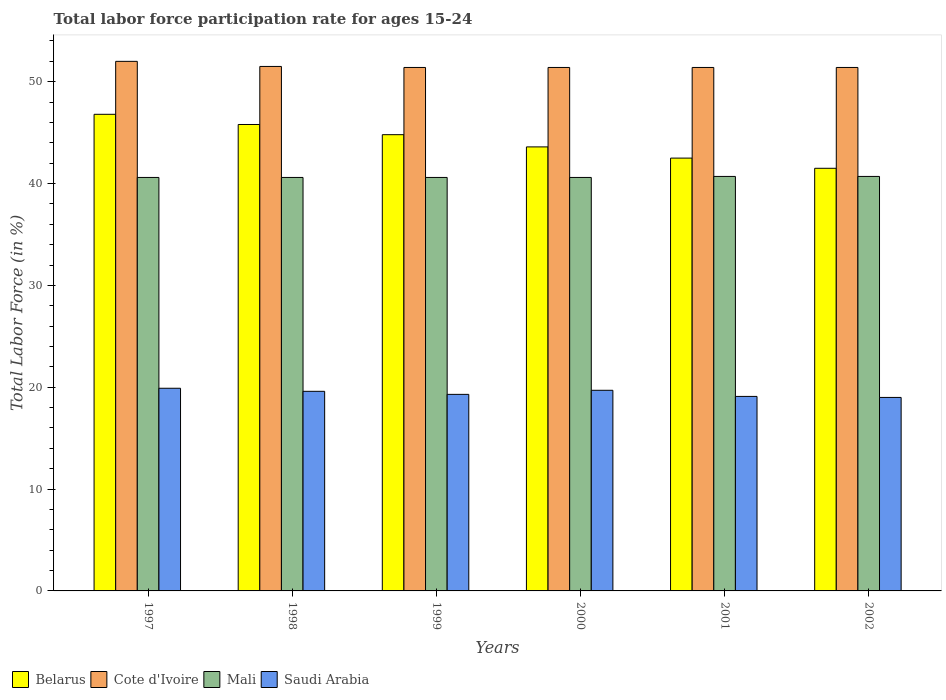Are the number of bars per tick equal to the number of legend labels?
Make the answer very short. Yes. How many bars are there on the 4th tick from the right?
Offer a terse response. 4. What is the labor force participation rate in Saudi Arabia in 1998?
Ensure brevity in your answer.  19.6. Across all years, what is the maximum labor force participation rate in Saudi Arabia?
Your answer should be very brief. 19.9. Across all years, what is the minimum labor force participation rate in Cote d'Ivoire?
Make the answer very short. 51.4. In which year was the labor force participation rate in Cote d'Ivoire minimum?
Your response must be concise. 1999. What is the total labor force participation rate in Saudi Arabia in the graph?
Provide a short and direct response. 116.6. What is the difference between the labor force participation rate in Belarus in 2000 and the labor force participation rate in Mali in 2001?
Offer a very short reply. 2.9. What is the average labor force participation rate in Cote d'Ivoire per year?
Make the answer very short. 51.52. In the year 1999, what is the difference between the labor force participation rate in Mali and labor force participation rate in Belarus?
Your answer should be compact. -4.2. In how many years, is the labor force participation rate in Cote d'Ivoire greater than 20 %?
Your response must be concise. 6. What is the ratio of the labor force participation rate in Saudi Arabia in 1997 to that in 1998?
Ensure brevity in your answer.  1.02. Is the labor force participation rate in Saudi Arabia in 1999 less than that in 2002?
Give a very brief answer. No. Is the difference between the labor force participation rate in Mali in 1998 and 1999 greater than the difference between the labor force participation rate in Belarus in 1998 and 1999?
Provide a short and direct response. No. What is the difference between the highest and the second highest labor force participation rate in Saudi Arabia?
Your answer should be very brief. 0.2. What is the difference between the highest and the lowest labor force participation rate in Belarus?
Offer a very short reply. 5.3. Is the sum of the labor force participation rate in Belarus in 1998 and 2001 greater than the maximum labor force participation rate in Saudi Arabia across all years?
Your answer should be compact. Yes. Is it the case that in every year, the sum of the labor force participation rate in Belarus and labor force participation rate in Saudi Arabia is greater than the sum of labor force participation rate in Mali and labor force participation rate in Cote d'Ivoire?
Provide a succinct answer. No. What does the 4th bar from the left in 2000 represents?
Give a very brief answer. Saudi Arabia. What does the 1st bar from the right in 2000 represents?
Provide a succinct answer. Saudi Arabia. Are all the bars in the graph horizontal?
Make the answer very short. No. Does the graph contain any zero values?
Keep it short and to the point. No. Does the graph contain grids?
Provide a succinct answer. No. Where does the legend appear in the graph?
Make the answer very short. Bottom left. How are the legend labels stacked?
Your answer should be very brief. Horizontal. What is the title of the graph?
Give a very brief answer. Total labor force participation rate for ages 15-24. What is the Total Labor Force (in %) of Belarus in 1997?
Offer a terse response. 46.8. What is the Total Labor Force (in %) of Cote d'Ivoire in 1997?
Ensure brevity in your answer.  52. What is the Total Labor Force (in %) in Mali in 1997?
Give a very brief answer. 40.6. What is the Total Labor Force (in %) in Saudi Arabia in 1997?
Your answer should be very brief. 19.9. What is the Total Labor Force (in %) in Belarus in 1998?
Your answer should be compact. 45.8. What is the Total Labor Force (in %) of Cote d'Ivoire in 1998?
Offer a terse response. 51.5. What is the Total Labor Force (in %) of Mali in 1998?
Offer a very short reply. 40.6. What is the Total Labor Force (in %) of Saudi Arabia in 1998?
Your answer should be very brief. 19.6. What is the Total Labor Force (in %) in Belarus in 1999?
Provide a short and direct response. 44.8. What is the Total Labor Force (in %) of Cote d'Ivoire in 1999?
Offer a very short reply. 51.4. What is the Total Labor Force (in %) in Mali in 1999?
Give a very brief answer. 40.6. What is the Total Labor Force (in %) in Saudi Arabia in 1999?
Your answer should be very brief. 19.3. What is the Total Labor Force (in %) of Belarus in 2000?
Give a very brief answer. 43.6. What is the Total Labor Force (in %) in Cote d'Ivoire in 2000?
Your answer should be compact. 51.4. What is the Total Labor Force (in %) of Mali in 2000?
Your answer should be compact. 40.6. What is the Total Labor Force (in %) in Saudi Arabia in 2000?
Offer a very short reply. 19.7. What is the Total Labor Force (in %) in Belarus in 2001?
Make the answer very short. 42.5. What is the Total Labor Force (in %) of Cote d'Ivoire in 2001?
Give a very brief answer. 51.4. What is the Total Labor Force (in %) in Mali in 2001?
Your response must be concise. 40.7. What is the Total Labor Force (in %) of Saudi Arabia in 2001?
Make the answer very short. 19.1. What is the Total Labor Force (in %) of Belarus in 2002?
Ensure brevity in your answer.  41.5. What is the Total Labor Force (in %) in Cote d'Ivoire in 2002?
Provide a succinct answer. 51.4. What is the Total Labor Force (in %) of Mali in 2002?
Your response must be concise. 40.7. What is the Total Labor Force (in %) in Saudi Arabia in 2002?
Make the answer very short. 19. Across all years, what is the maximum Total Labor Force (in %) of Belarus?
Ensure brevity in your answer.  46.8. Across all years, what is the maximum Total Labor Force (in %) of Mali?
Offer a terse response. 40.7. Across all years, what is the maximum Total Labor Force (in %) in Saudi Arabia?
Give a very brief answer. 19.9. Across all years, what is the minimum Total Labor Force (in %) of Belarus?
Your answer should be compact. 41.5. Across all years, what is the minimum Total Labor Force (in %) of Cote d'Ivoire?
Your answer should be compact. 51.4. Across all years, what is the minimum Total Labor Force (in %) of Mali?
Ensure brevity in your answer.  40.6. What is the total Total Labor Force (in %) of Belarus in the graph?
Make the answer very short. 265. What is the total Total Labor Force (in %) in Cote d'Ivoire in the graph?
Your answer should be very brief. 309.1. What is the total Total Labor Force (in %) of Mali in the graph?
Your response must be concise. 243.8. What is the total Total Labor Force (in %) of Saudi Arabia in the graph?
Give a very brief answer. 116.6. What is the difference between the Total Labor Force (in %) of Belarus in 1997 and that in 1998?
Make the answer very short. 1. What is the difference between the Total Labor Force (in %) in Cote d'Ivoire in 1997 and that in 1998?
Your response must be concise. 0.5. What is the difference between the Total Labor Force (in %) in Saudi Arabia in 1997 and that in 1998?
Your answer should be very brief. 0.3. What is the difference between the Total Labor Force (in %) in Mali in 1997 and that in 1999?
Make the answer very short. 0. What is the difference between the Total Labor Force (in %) in Saudi Arabia in 1997 and that in 1999?
Offer a very short reply. 0.6. What is the difference between the Total Labor Force (in %) of Mali in 1997 and that in 2000?
Keep it short and to the point. 0. What is the difference between the Total Labor Force (in %) of Mali in 1997 and that in 2001?
Keep it short and to the point. -0.1. What is the difference between the Total Labor Force (in %) of Saudi Arabia in 1997 and that in 2001?
Keep it short and to the point. 0.8. What is the difference between the Total Labor Force (in %) in Belarus in 1997 and that in 2002?
Your answer should be compact. 5.3. What is the difference between the Total Labor Force (in %) of Mali in 1997 and that in 2002?
Give a very brief answer. -0.1. What is the difference between the Total Labor Force (in %) of Belarus in 1998 and that in 1999?
Provide a short and direct response. 1. What is the difference between the Total Labor Force (in %) in Saudi Arabia in 1998 and that in 1999?
Ensure brevity in your answer.  0.3. What is the difference between the Total Labor Force (in %) of Belarus in 1998 and that in 2000?
Provide a succinct answer. 2.2. What is the difference between the Total Labor Force (in %) of Cote d'Ivoire in 1998 and that in 2000?
Provide a succinct answer. 0.1. What is the difference between the Total Labor Force (in %) in Mali in 1998 and that in 2000?
Your answer should be very brief. 0. What is the difference between the Total Labor Force (in %) in Belarus in 1998 and that in 2001?
Give a very brief answer. 3.3. What is the difference between the Total Labor Force (in %) of Saudi Arabia in 1998 and that in 2001?
Offer a terse response. 0.5. What is the difference between the Total Labor Force (in %) of Cote d'Ivoire in 1998 and that in 2002?
Your answer should be very brief. 0.1. What is the difference between the Total Labor Force (in %) of Mali in 1998 and that in 2002?
Your answer should be compact. -0.1. What is the difference between the Total Labor Force (in %) in Belarus in 1999 and that in 2000?
Make the answer very short. 1.2. What is the difference between the Total Labor Force (in %) of Cote d'Ivoire in 1999 and that in 2000?
Ensure brevity in your answer.  0. What is the difference between the Total Labor Force (in %) in Mali in 1999 and that in 2000?
Provide a succinct answer. 0. What is the difference between the Total Labor Force (in %) of Saudi Arabia in 1999 and that in 2000?
Offer a terse response. -0.4. What is the difference between the Total Labor Force (in %) of Cote d'Ivoire in 1999 and that in 2001?
Your answer should be very brief. 0. What is the difference between the Total Labor Force (in %) of Mali in 1999 and that in 2001?
Offer a terse response. -0.1. What is the difference between the Total Labor Force (in %) of Saudi Arabia in 1999 and that in 2001?
Offer a very short reply. 0.2. What is the difference between the Total Labor Force (in %) in Cote d'Ivoire in 1999 and that in 2002?
Give a very brief answer. 0. What is the difference between the Total Labor Force (in %) of Mali in 1999 and that in 2002?
Provide a short and direct response. -0.1. What is the difference between the Total Labor Force (in %) in Cote d'Ivoire in 2000 and that in 2001?
Make the answer very short. 0. What is the difference between the Total Labor Force (in %) of Belarus in 2000 and that in 2002?
Give a very brief answer. 2.1. What is the difference between the Total Labor Force (in %) in Saudi Arabia in 2000 and that in 2002?
Your response must be concise. 0.7. What is the difference between the Total Labor Force (in %) of Mali in 2001 and that in 2002?
Provide a short and direct response. 0. What is the difference between the Total Labor Force (in %) in Saudi Arabia in 2001 and that in 2002?
Your answer should be very brief. 0.1. What is the difference between the Total Labor Force (in %) in Belarus in 1997 and the Total Labor Force (in %) in Mali in 1998?
Your response must be concise. 6.2. What is the difference between the Total Labor Force (in %) of Belarus in 1997 and the Total Labor Force (in %) of Saudi Arabia in 1998?
Your response must be concise. 27.2. What is the difference between the Total Labor Force (in %) in Cote d'Ivoire in 1997 and the Total Labor Force (in %) in Saudi Arabia in 1998?
Offer a very short reply. 32.4. What is the difference between the Total Labor Force (in %) of Mali in 1997 and the Total Labor Force (in %) of Saudi Arabia in 1998?
Keep it short and to the point. 21. What is the difference between the Total Labor Force (in %) of Cote d'Ivoire in 1997 and the Total Labor Force (in %) of Mali in 1999?
Provide a short and direct response. 11.4. What is the difference between the Total Labor Force (in %) of Cote d'Ivoire in 1997 and the Total Labor Force (in %) of Saudi Arabia in 1999?
Offer a very short reply. 32.7. What is the difference between the Total Labor Force (in %) in Mali in 1997 and the Total Labor Force (in %) in Saudi Arabia in 1999?
Your answer should be very brief. 21.3. What is the difference between the Total Labor Force (in %) in Belarus in 1997 and the Total Labor Force (in %) in Saudi Arabia in 2000?
Keep it short and to the point. 27.1. What is the difference between the Total Labor Force (in %) of Cote d'Ivoire in 1997 and the Total Labor Force (in %) of Saudi Arabia in 2000?
Ensure brevity in your answer.  32.3. What is the difference between the Total Labor Force (in %) in Mali in 1997 and the Total Labor Force (in %) in Saudi Arabia in 2000?
Keep it short and to the point. 20.9. What is the difference between the Total Labor Force (in %) in Belarus in 1997 and the Total Labor Force (in %) in Mali in 2001?
Make the answer very short. 6.1. What is the difference between the Total Labor Force (in %) of Belarus in 1997 and the Total Labor Force (in %) of Saudi Arabia in 2001?
Provide a short and direct response. 27.7. What is the difference between the Total Labor Force (in %) of Cote d'Ivoire in 1997 and the Total Labor Force (in %) of Mali in 2001?
Provide a succinct answer. 11.3. What is the difference between the Total Labor Force (in %) in Cote d'Ivoire in 1997 and the Total Labor Force (in %) in Saudi Arabia in 2001?
Provide a short and direct response. 32.9. What is the difference between the Total Labor Force (in %) of Belarus in 1997 and the Total Labor Force (in %) of Saudi Arabia in 2002?
Your answer should be compact. 27.8. What is the difference between the Total Labor Force (in %) in Cote d'Ivoire in 1997 and the Total Labor Force (in %) in Saudi Arabia in 2002?
Make the answer very short. 33. What is the difference between the Total Labor Force (in %) of Mali in 1997 and the Total Labor Force (in %) of Saudi Arabia in 2002?
Keep it short and to the point. 21.6. What is the difference between the Total Labor Force (in %) of Belarus in 1998 and the Total Labor Force (in %) of Cote d'Ivoire in 1999?
Keep it short and to the point. -5.6. What is the difference between the Total Labor Force (in %) of Belarus in 1998 and the Total Labor Force (in %) of Mali in 1999?
Provide a succinct answer. 5.2. What is the difference between the Total Labor Force (in %) in Cote d'Ivoire in 1998 and the Total Labor Force (in %) in Mali in 1999?
Offer a very short reply. 10.9. What is the difference between the Total Labor Force (in %) of Cote d'Ivoire in 1998 and the Total Labor Force (in %) of Saudi Arabia in 1999?
Give a very brief answer. 32.2. What is the difference between the Total Labor Force (in %) in Mali in 1998 and the Total Labor Force (in %) in Saudi Arabia in 1999?
Offer a terse response. 21.3. What is the difference between the Total Labor Force (in %) in Belarus in 1998 and the Total Labor Force (in %) in Cote d'Ivoire in 2000?
Make the answer very short. -5.6. What is the difference between the Total Labor Force (in %) in Belarus in 1998 and the Total Labor Force (in %) in Mali in 2000?
Give a very brief answer. 5.2. What is the difference between the Total Labor Force (in %) of Belarus in 1998 and the Total Labor Force (in %) of Saudi Arabia in 2000?
Ensure brevity in your answer.  26.1. What is the difference between the Total Labor Force (in %) in Cote d'Ivoire in 1998 and the Total Labor Force (in %) in Saudi Arabia in 2000?
Offer a terse response. 31.8. What is the difference between the Total Labor Force (in %) in Mali in 1998 and the Total Labor Force (in %) in Saudi Arabia in 2000?
Your answer should be compact. 20.9. What is the difference between the Total Labor Force (in %) of Belarus in 1998 and the Total Labor Force (in %) of Cote d'Ivoire in 2001?
Your response must be concise. -5.6. What is the difference between the Total Labor Force (in %) of Belarus in 1998 and the Total Labor Force (in %) of Mali in 2001?
Make the answer very short. 5.1. What is the difference between the Total Labor Force (in %) in Belarus in 1998 and the Total Labor Force (in %) in Saudi Arabia in 2001?
Your answer should be very brief. 26.7. What is the difference between the Total Labor Force (in %) in Cote d'Ivoire in 1998 and the Total Labor Force (in %) in Saudi Arabia in 2001?
Make the answer very short. 32.4. What is the difference between the Total Labor Force (in %) of Belarus in 1998 and the Total Labor Force (in %) of Mali in 2002?
Provide a short and direct response. 5.1. What is the difference between the Total Labor Force (in %) in Belarus in 1998 and the Total Labor Force (in %) in Saudi Arabia in 2002?
Make the answer very short. 26.8. What is the difference between the Total Labor Force (in %) in Cote d'Ivoire in 1998 and the Total Labor Force (in %) in Saudi Arabia in 2002?
Your response must be concise. 32.5. What is the difference between the Total Labor Force (in %) in Mali in 1998 and the Total Labor Force (in %) in Saudi Arabia in 2002?
Provide a short and direct response. 21.6. What is the difference between the Total Labor Force (in %) of Belarus in 1999 and the Total Labor Force (in %) of Cote d'Ivoire in 2000?
Your answer should be very brief. -6.6. What is the difference between the Total Labor Force (in %) in Belarus in 1999 and the Total Labor Force (in %) in Mali in 2000?
Ensure brevity in your answer.  4.2. What is the difference between the Total Labor Force (in %) of Belarus in 1999 and the Total Labor Force (in %) of Saudi Arabia in 2000?
Your response must be concise. 25.1. What is the difference between the Total Labor Force (in %) of Cote d'Ivoire in 1999 and the Total Labor Force (in %) of Mali in 2000?
Offer a very short reply. 10.8. What is the difference between the Total Labor Force (in %) of Cote d'Ivoire in 1999 and the Total Labor Force (in %) of Saudi Arabia in 2000?
Keep it short and to the point. 31.7. What is the difference between the Total Labor Force (in %) in Mali in 1999 and the Total Labor Force (in %) in Saudi Arabia in 2000?
Ensure brevity in your answer.  20.9. What is the difference between the Total Labor Force (in %) of Belarus in 1999 and the Total Labor Force (in %) of Saudi Arabia in 2001?
Your answer should be compact. 25.7. What is the difference between the Total Labor Force (in %) of Cote d'Ivoire in 1999 and the Total Labor Force (in %) of Saudi Arabia in 2001?
Your answer should be very brief. 32.3. What is the difference between the Total Labor Force (in %) in Belarus in 1999 and the Total Labor Force (in %) in Cote d'Ivoire in 2002?
Give a very brief answer. -6.6. What is the difference between the Total Labor Force (in %) of Belarus in 1999 and the Total Labor Force (in %) of Mali in 2002?
Offer a very short reply. 4.1. What is the difference between the Total Labor Force (in %) in Belarus in 1999 and the Total Labor Force (in %) in Saudi Arabia in 2002?
Offer a terse response. 25.8. What is the difference between the Total Labor Force (in %) in Cote d'Ivoire in 1999 and the Total Labor Force (in %) in Saudi Arabia in 2002?
Your answer should be very brief. 32.4. What is the difference between the Total Labor Force (in %) in Mali in 1999 and the Total Labor Force (in %) in Saudi Arabia in 2002?
Give a very brief answer. 21.6. What is the difference between the Total Labor Force (in %) of Belarus in 2000 and the Total Labor Force (in %) of Mali in 2001?
Your answer should be very brief. 2.9. What is the difference between the Total Labor Force (in %) in Belarus in 2000 and the Total Labor Force (in %) in Saudi Arabia in 2001?
Make the answer very short. 24.5. What is the difference between the Total Labor Force (in %) in Cote d'Ivoire in 2000 and the Total Labor Force (in %) in Saudi Arabia in 2001?
Your answer should be compact. 32.3. What is the difference between the Total Labor Force (in %) in Belarus in 2000 and the Total Labor Force (in %) in Mali in 2002?
Your response must be concise. 2.9. What is the difference between the Total Labor Force (in %) of Belarus in 2000 and the Total Labor Force (in %) of Saudi Arabia in 2002?
Your answer should be compact. 24.6. What is the difference between the Total Labor Force (in %) of Cote d'Ivoire in 2000 and the Total Labor Force (in %) of Mali in 2002?
Your response must be concise. 10.7. What is the difference between the Total Labor Force (in %) in Cote d'Ivoire in 2000 and the Total Labor Force (in %) in Saudi Arabia in 2002?
Provide a succinct answer. 32.4. What is the difference between the Total Labor Force (in %) in Mali in 2000 and the Total Labor Force (in %) in Saudi Arabia in 2002?
Ensure brevity in your answer.  21.6. What is the difference between the Total Labor Force (in %) in Cote d'Ivoire in 2001 and the Total Labor Force (in %) in Saudi Arabia in 2002?
Your answer should be very brief. 32.4. What is the difference between the Total Labor Force (in %) in Mali in 2001 and the Total Labor Force (in %) in Saudi Arabia in 2002?
Your response must be concise. 21.7. What is the average Total Labor Force (in %) in Belarus per year?
Ensure brevity in your answer.  44.17. What is the average Total Labor Force (in %) in Cote d'Ivoire per year?
Provide a short and direct response. 51.52. What is the average Total Labor Force (in %) in Mali per year?
Offer a terse response. 40.63. What is the average Total Labor Force (in %) in Saudi Arabia per year?
Offer a terse response. 19.43. In the year 1997, what is the difference between the Total Labor Force (in %) in Belarus and Total Labor Force (in %) in Cote d'Ivoire?
Your answer should be compact. -5.2. In the year 1997, what is the difference between the Total Labor Force (in %) of Belarus and Total Labor Force (in %) of Saudi Arabia?
Your answer should be compact. 26.9. In the year 1997, what is the difference between the Total Labor Force (in %) in Cote d'Ivoire and Total Labor Force (in %) in Mali?
Ensure brevity in your answer.  11.4. In the year 1997, what is the difference between the Total Labor Force (in %) of Cote d'Ivoire and Total Labor Force (in %) of Saudi Arabia?
Ensure brevity in your answer.  32.1. In the year 1997, what is the difference between the Total Labor Force (in %) of Mali and Total Labor Force (in %) of Saudi Arabia?
Offer a terse response. 20.7. In the year 1998, what is the difference between the Total Labor Force (in %) of Belarus and Total Labor Force (in %) of Mali?
Offer a very short reply. 5.2. In the year 1998, what is the difference between the Total Labor Force (in %) in Belarus and Total Labor Force (in %) in Saudi Arabia?
Offer a very short reply. 26.2. In the year 1998, what is the difference between the Total Labor Force (in %) of Cote d'Ivoire and Total Labor Force (in %) of Saudi Arabia?
Provide a short and direct response. 31.9. In the year 1998, what is the difference between the Total Labor Force (in %) in Mali and Total Labor Force (in %) in Saudi Arabia?
Make the answer very short. 21. In the year 1999, what is the difference between the Total Labor Force (in %) in Belarus and Total Labor Force (in %) in Mali?
Your answer should be very brief. 4.2. In the year 1999, what is the difference between the Total Labor Force (in %) of Belarus and Total Labor Force (in %) of Saudi Arabia?
Your response must be concise. 25.5. In the year 1999, what is the difference between the Total Labor Force (in %) of Cote d'Ivoire and Total Labor Force (in %) of Saudi Arabia?
Give a very brief answer. 32.1. In the year 1999, what is the difference between the Total Labor Force (in %) in Mali and Total Labor Force (in %) in Saudi Arabia?
Your answer should be compact. 21.3. In the year 2000, what is the difference between the Total Labor Force (in %) of Belarus and Total Labor Force (in %) of Cote d'Ivoire?
Your answer should be compact. -7.8. In the year 2000, what is the difference between the Total Labor Force (in %) in Belarus and Total Labor Force (in %) in Mali?
Your answer should be very brief. 3. In the year 2000, what is the difference between the Total Labor Force (in %) in Belarus and Total Labor Force (in %) in Saudi Arabia?
Offer a very short reply. 23.9. In the year 2000, what is the difference between the Total Labor Force (in %) in Cote d'Ivoire and Total Labor Force (in %) in Saudi Arabia?
Provide a short and direct response. 31.7. In the year 2000, what is the difference between the Total Labor Force (in %) of Mali and Total Labor Force (in %) of Saudi Arabia?
Provide a short and direct response. 20.9. In the year 2001, what is the difference between the Total Labor Force (in %) of Belarus and Total Labor Force (in %) of Mali?
Offer a very short reply. 1.8. In the year 2001, what is the difference between the Total Labor Force (in %) of Belarus and Total Labor Force (in %) of Saudi Arabia?
Keep it short and to the point. 23.4. In the year 2001, what is the difference between the Total Labor Force (in %) of Cote d'Ivoire and Total Labor Force (in %) of Mali?
Your response must be concise. 10.7. In the year 2001, what is the difference between the Total Labor Force (in %) in Cote d'Ivoire and Total Labor Force (in %) in Saudi Arabia?
Your response must be concise. 32.3. In the year 2001, what is the difference between the Total Labor Force (in %) of Mali and Total Labor Force (in %) of Saudi Arabia?
Your answer should be very brief. 21.6. In the year 2002, what is the difference between the Total Labor Force (in %) in Belarus and Total Labor Force (in %) in Saudi Arabia?
Keep it short and to the point. 22.5. In the year 2002, what is the difference between the Total Labor Force (in %) in Cote d'Ivoire and Total Labor Force (in %) in Mali?
Provide a short and direct response. 10.7. In the year 2002, what is the difference between the Total Labor Force (in %) in Cote d'Ivoire and Total Labor Force (in %) in Saudi Arabia?
Make the answer very short. 32.4. In the year 2002, what is the difference between the Total Labor Force (in %) in Mali and Total Labor Force (in %) in Saudi Arabia?
Your answer should be very brief. 21.7. What is the ratio of the Total Labor Force (in %) of Belarus in 1997 to that in 1998?
Give a very brief answer. 1.02. What is the ratio of the Total Labor Force (in %) of Cote d'Ivoire in 1997 to that in 1998?
Keep it short and to the point. 1.01. What is the ratio of the Total Labor Force (in %) in Saudi Arabia in 1997 to that in 1998?
Your answer should be compact. 1.02. What is the ratio of the Total Labor Force (in %) in Belarus in 1997 to that in 1999?
Your answer should be compact. 1.04. What is the ratio of the Total Labor Force (in %) in Cote d'Ivoire in 1997 to that in 1999?
Your answer should be compact. 1.01. What is the ratio of the Total Labor Force (in %) of Saudi Arabia in 1997 to that in 1999?
Offer a very short reply. 1.03. What is the ratio of the Total Labor Force (in %) in Belarus in 1997 to that in 2000?
Your answer should be compact. 1.07. What is the ratio of the Total Labor Force (in %) in Cote d'Ivoire in 1997 to that in 2000?
Offer a terse response. 1.01. What is the ratio of the Total Labor Force (in %) in Mali in 1997 to that in 2000?
Provide a short and direct response. 1. What is the ratio of the Total Labor Force (in %) in Saudi Arabia in 1997 to that in 2000?
Your response must be concise. 1.01. What is the ratio of the Total Labor Force (in %) in Belarus in 1997 to that in 2001?
Your answer should be compact. 1.1. What is the ratio of the Total Labor Force (in %) of Cote d'Ivoire in 1997 to that in 2001?
Provide a succinct answer. 1.01. What is the ratio of the Total Labor Force (in %) of Saudi Arabia in 1997 to that in 2001?
Give a very brief answer. 1.04. What is the ratio of the Total Labor Force (in %) of Belarus in 1997 to that in 2002?
Offer a terse response. 1.13. What is the ratio of the Total Labor Force (in %) of Cote d'Ivoire in 1997 to that in 2002?
Provide a succinct answer. 1.01. What is the ratio of the Total Labor Force (in %) in Mali in 1997 to that in 2002?
Provide a succinct answer. 1. What is the ratio of the Total Labor Force (in %) of Saudi Arabia in 1997 to that in 2002?
Provide a succinct answer. 1.05. What is the ratio of the Total Labor Force (in %) of Belarus in 1998 to that in 1999?
Provide a succinct answer. 1.02. What is the ratio of the Total Labor Force (in %) of Cote d'Ivoire in 1998 to that in 1999?
Offer a very short reply. 1. What is the ratio of the Total Labor Force (in %) in Saudi Arabia in 1998 to that in 1999?
Your answer should be compact. 1.02. What is the ratio of the Total Labor Force (in %) in Belarus in 1998 to that in 2000?
Your answer should be very brief. 1.05. What is the ratio of the Total Labor Force (in %) of Mali in 1998 to that in 2000?
Provide a succinct answer. 1. What is the ratio of the Total Labor Force (in %) in Saudi Arabia in 1998 to that in 2000?
Offer a very short reply. 0.99. What is the ratio of the Total Labor Force (in %) of Belarus in 1998 to that in 2001?
Ensure brevity in your answer.  1.08. What is the ratio of the Total Labor Force (in %) in Cote d'Ivoire in 1998 to that in 2001?
Your response must be concise. 1. What is the ratio of the Total Labor Force (in %) in Saudi Arabia in 1998 to that in 2001?
Keep it short and to the point. 1.03. What is the ratio of the Total Labor Force (in %) of Belarus in 1998 to that in 2002?
Your response must be concise. 1.1. What is the ratio of the Total Labor Force (in %) in Mali in 1998 to that in 2002?
Your response must be concise. 1. What is the ratio of the Total Labor Force (in %) in Saudi Arabia in 1998 to that in 2002?
Your answer should be very brief. 1.03. What is the ratio of the Total Labor Force (in %) of Belarus in 1999 to that in 2000?
Provide a short and direct response. 1.03. What is the ratio of the Total Labor Force (in %) of Saudi Arabia in 1999 to that in 2000?
Your answer should be very brief. 0.98. What is the ratio of the Total Labor Force (in %) in Belarus in 1999 to that in 2001?
Your response must be concise. 1.05. What is the ratio of the Total Labor Force (in %) in Cote d'Ivoire in 1999 to that in 2001?
Offer a very short reply. 1. What is the ratio of the Total Labor Force (in %) of Mali in 1999 to that in 2001?
Make the answer very short. 1. What is the ratio of the Total Labor Force (in %) in Saudi Arabia in 1999 to that in 2001?
Offer a terse response. 1.01. What is the ratio of the Total Labor Force (in %) of Belarus in 1999 to that in 2002?
Offer a very short reply. 1.08. What is the ratio of the Total Labor Force (in %) in Saudi Arabia in 1999 to that in 2002?
Keep it short and to the point. 1.02. What is the ratio of the Total Labor Force (in %) of Belarus in 2000 to that in 2001?
Keep it short and to the point. 1.03. What is the ratio of the Total Labor Force (in %) of Cote d'Ivoire in 2000 to that in 2001?
Give a very brief answer. 1. What is the ratio of the Total Labor Force (in %) in Mali in 2000 to that in 2001?
Offer a very short reply. 1. What is the ratio of the Total Labor Force (in %) of Saudi Arabia in 2000 to that in 2001?
Provide a short and direct response. 1.03. What is the ratio of the Total Labor Force (in %) in Belarus in 2000 to that in 2002?
Offer a terse response. 1.05. What is the ratio of the Total Labor Force (in %) in Cote d'Ivoire in 2000 to that in 2002?
Your answer should be compact. 1. What is the ratio of the Total Labor Force (in %) in Mali in 2000 to that in 2002?
Give a very brief answer. 1. What is the ratio of the Total Labor Force (in %) in Saudi Arabia in 2000 to that in 2002?
Offer a terse response. 1.04. What is the ratio of the Total Labor Force (in %) of Belarus in 2001 to that in 2002?
Make the answer very short. 1.02. What is the ratio of the Total Labor Force (in %) in Cote d'Ivoire in 2001 to that in 2002?
Offer a very short reply. 1. What is the difference between the highest and the second highest Total Labor Force (in %) of Cote d'Ivoire?
Give a very brief answer. 0.5. What is the difference between the highest and the second highest Total Labor Force (in %) in Mali?
Your answer should be very brief. 0. What is the difference between the highest and the second highest Total Labor Force (in %) in Saudi Arabia?
Ensure brevity in your answer.  0.2. What is the difference between the highest and the lowest Total Labor Force (in %) of Saudi Arabia?
Provide a short and direct response. 0.9. 